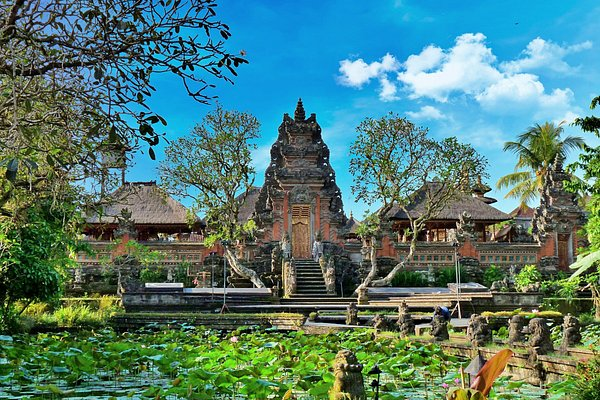Can you elaborate on the elements of the picture provided? The image beautifully captures the tranquil Ubud Water Palace in Bali, Indonesia, a fine example of classic Balinese architecture. The palace is set amidst a lush, verdant landscape. The primary structure, adorned with intricate carvings and ornate roofs, stands majestically at the center. Surrounding the palace is a serene pond, brimming with lily pads and bordered by tropical flora, its still waters mirroring the elegant edifices. The vivid blue sky above, punctuated by wispy white clouds, and the luxuriant greenery encapsulates the peaceful ambiance of the locale. The perspective of the photo offers a comprehensive glimpse into the entire palace complex, immersing the viewer in its serene and breathtaking beauty. 